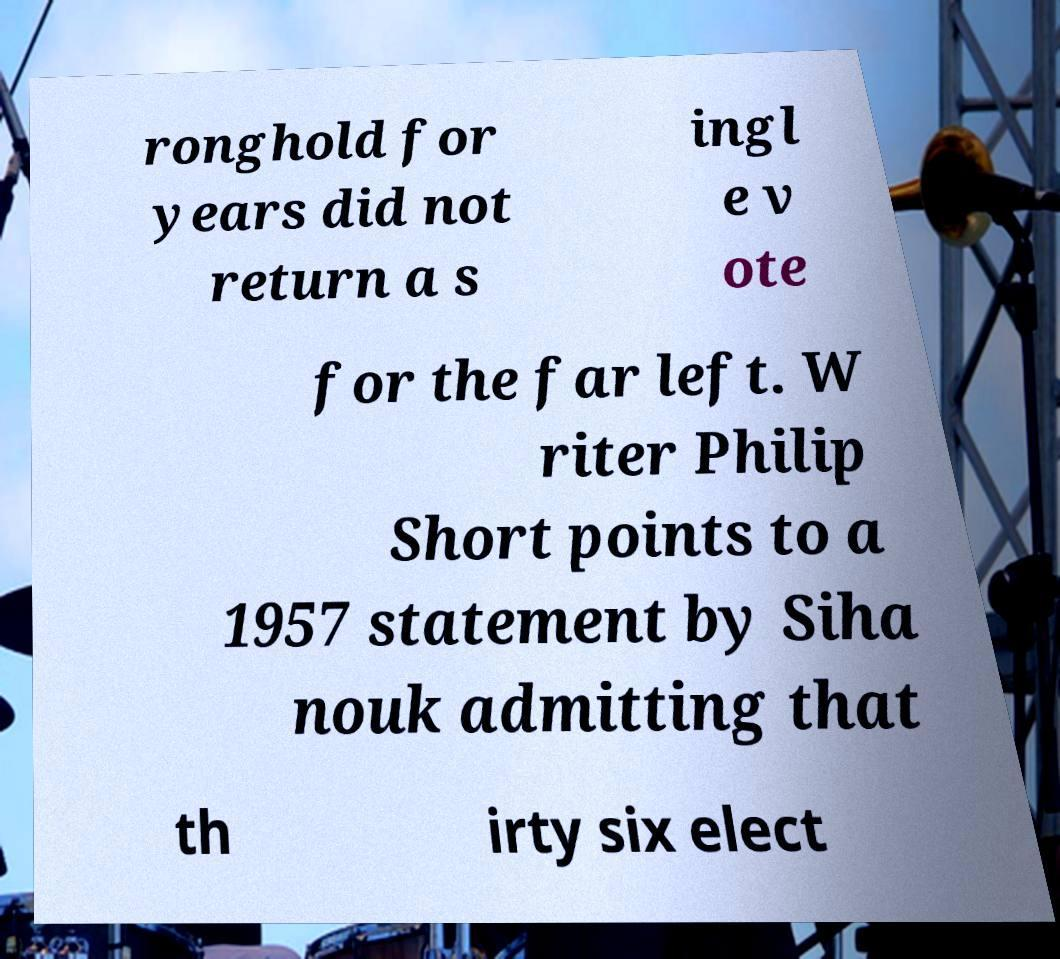Please read and relay the text visible in this image. What does it say? ronghold for years did not return a s ingl e v ote for the far left. W riter Philip Short points to a 1957 statement by Siha nouk admitting that th irty six elect 